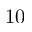Convert formula to latex. <formula><loc_0><loc_0><loc_500><loc_500>1 0</formula> 